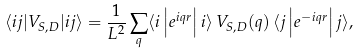<formula> <loc_0><loc_0><loc_500><loc_500>\langle i j | V _ { S , D } | i j \rangle = \frac { 1 } { L ^ { 2 } } \sum _ { q } \langle i \left | e ^ { i { q r } } \right | i \rangle \, V _ { S , D } ( { q } ) \, \langle j \left | e ^ { - i { q r } } \right | j \rangle ,</formula> 